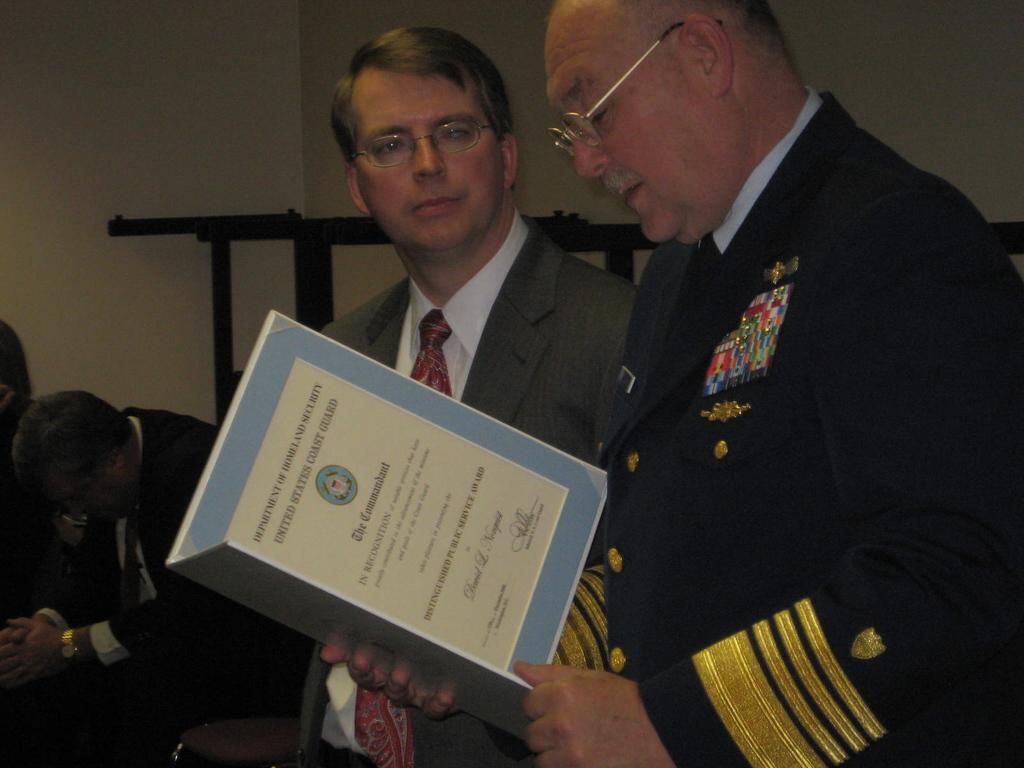Describe this image in one or two sentences. In this image, we can see people wearing clothes. There is a person on the right side of the image holding a file with his hands. There is an object in front of the wall. 